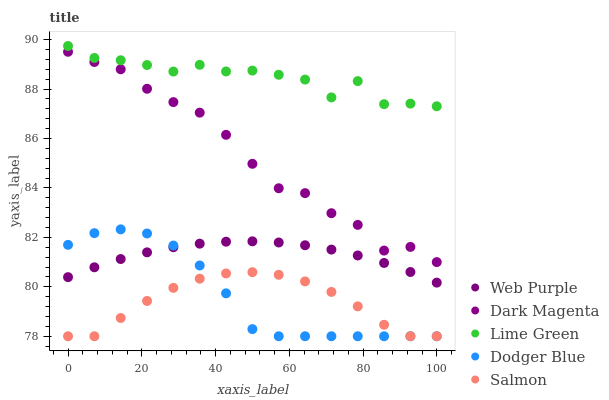Does Salmon have the minimum area under the curve?
Answer yes or no. Yes. Does Lime Green have the maximum area under the curve?
Answer yes or no. Yes. Does Web Purple have the minimum area under the curve?
Answer yes or no. No. Does Web Purple have the maximum area under the curve?
Answer yes or no. No. Is Web Purple the smoothest?
Answer yes or no. Yes. Is Lime Green the roughest?
Answer yes or no. Yes. Is Lime Green the smoothest?
Answer yes or no. No. Is Web Purple the roughest?
Answer yes or no. No. Does Dodger Blue have the lowest value?
Answer yes or no. Yes. Does Web Purple have the lowest value?
Answer yes or no. No. Does Lime Green have the highest value?
Answer yes or no. Yes. Does Web Purple have the highest value?
Answer yes or no. No. Is Web Purple less than Dark Magenta?
Answer yes or no. Yes. Is Lime Green greater than Dark Magenta?
Answer yes or no. Yes. Does Web Purple intersect Dodger Blue?
Answer yes or no. Yes. Is Web Purple less than Dodger Blue?
Answer yes or no. No. Is Web Purple greater than Dodger Blue?
Answer yes or no. No. Does Web Purple intersect Dark Magenta?
Answer yes or no. No. 